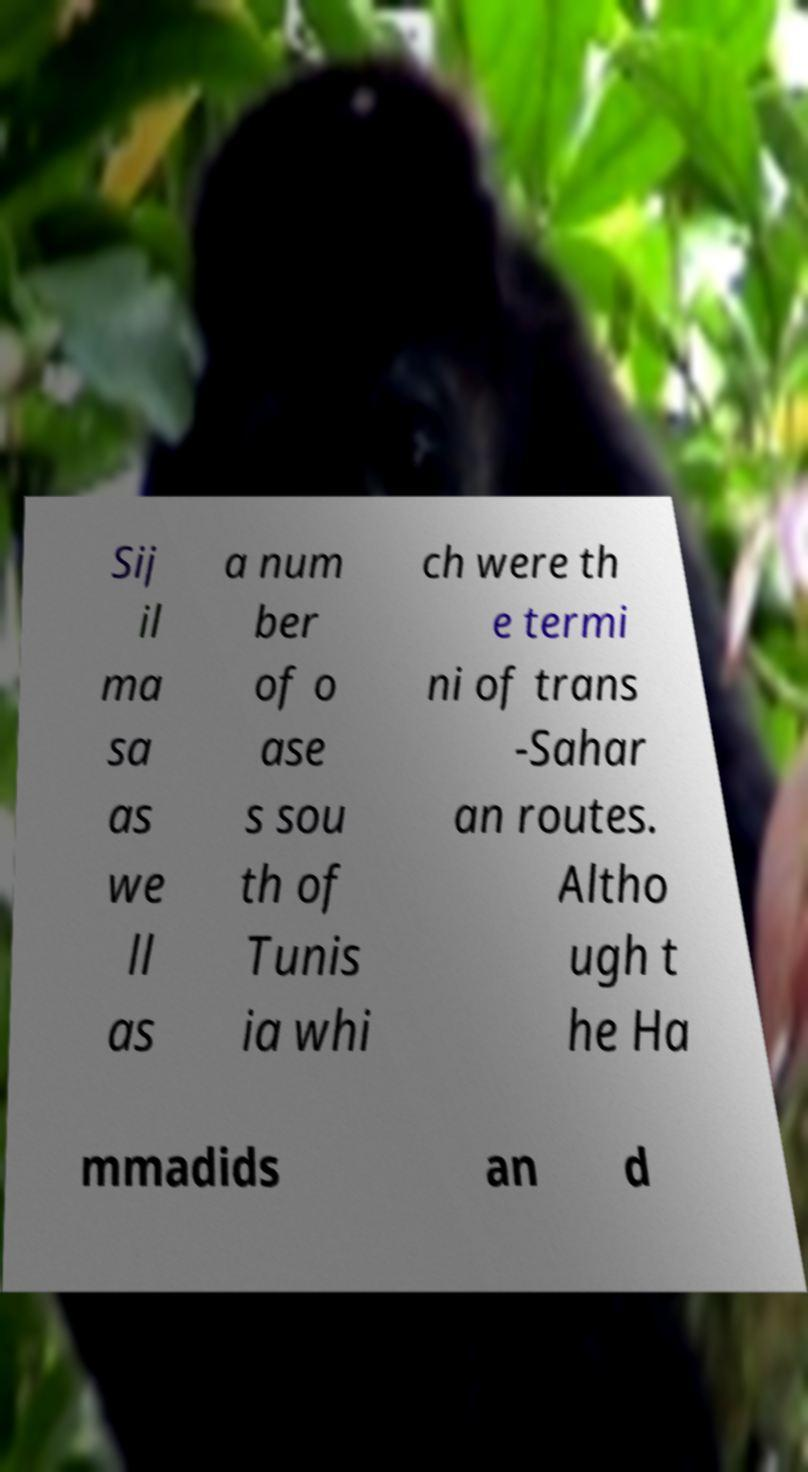Could you assist in decoding the text presented in this image and type it out clearly? Sij il ma sa as we ll as a num ber of o ase s sou th of Tunis ia whi ch were th e termi ni of trans -Sahar an routes. Altho ugh t he Ha mmadids an d 